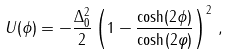<formula> <loc_0><loc_0><loc_500><loc_500>U ( \phi ) = - \frac { \Delta _ { 0 } ^ { 2 } } { 2 } \left ( 1 - \frac { \cosh ( 2 \phi ) } { \cosh ( 2 \varphi ) } \right ) ^ { 2 } \, ,</formula> 